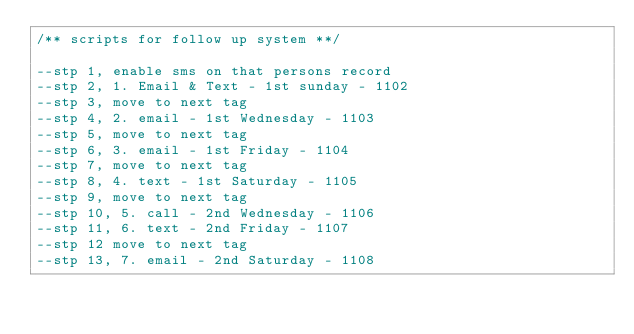<code> <loc_0><loc_0><loc_500><loc_500><_SQL_>/** scripts for follow up system **/

--stp 1, enable sms on that persons record
--stp 2, 1. Email & Text - 1st sunday - 1102
--stp 3, move to next tag
--stp 4, 2. email - 1st Wednesday - 1103
--stp 5, move to next tag
--stp 6, 3. email - 1st Friday - 1104
--stp 7, move to next tag
--stp 8, 4. text - 1st Saturday - 1105
--stp 9, move to next tag
--stp 10, 5. call - 2nd Wednesday - 1106
--stp 11, 6. text - 2nd Friday - 1107
--stp 12 move to next tag
--stp 13, 7. email - 2nd Saturday - 1108</code> 